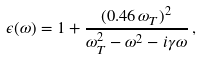Convert formula to latex. <formula><loc_0><loc_0><loc_500><loc_500>\epsilon ( \omega ) = 1 + \frac { ( 0 . 4 6 \, \omega _ { T } ) ^ { 2 } } { \omega _ { T } ^ { 2 } - \omega ^ { 2 } - i \gamma \omega } \, ,</formula> 